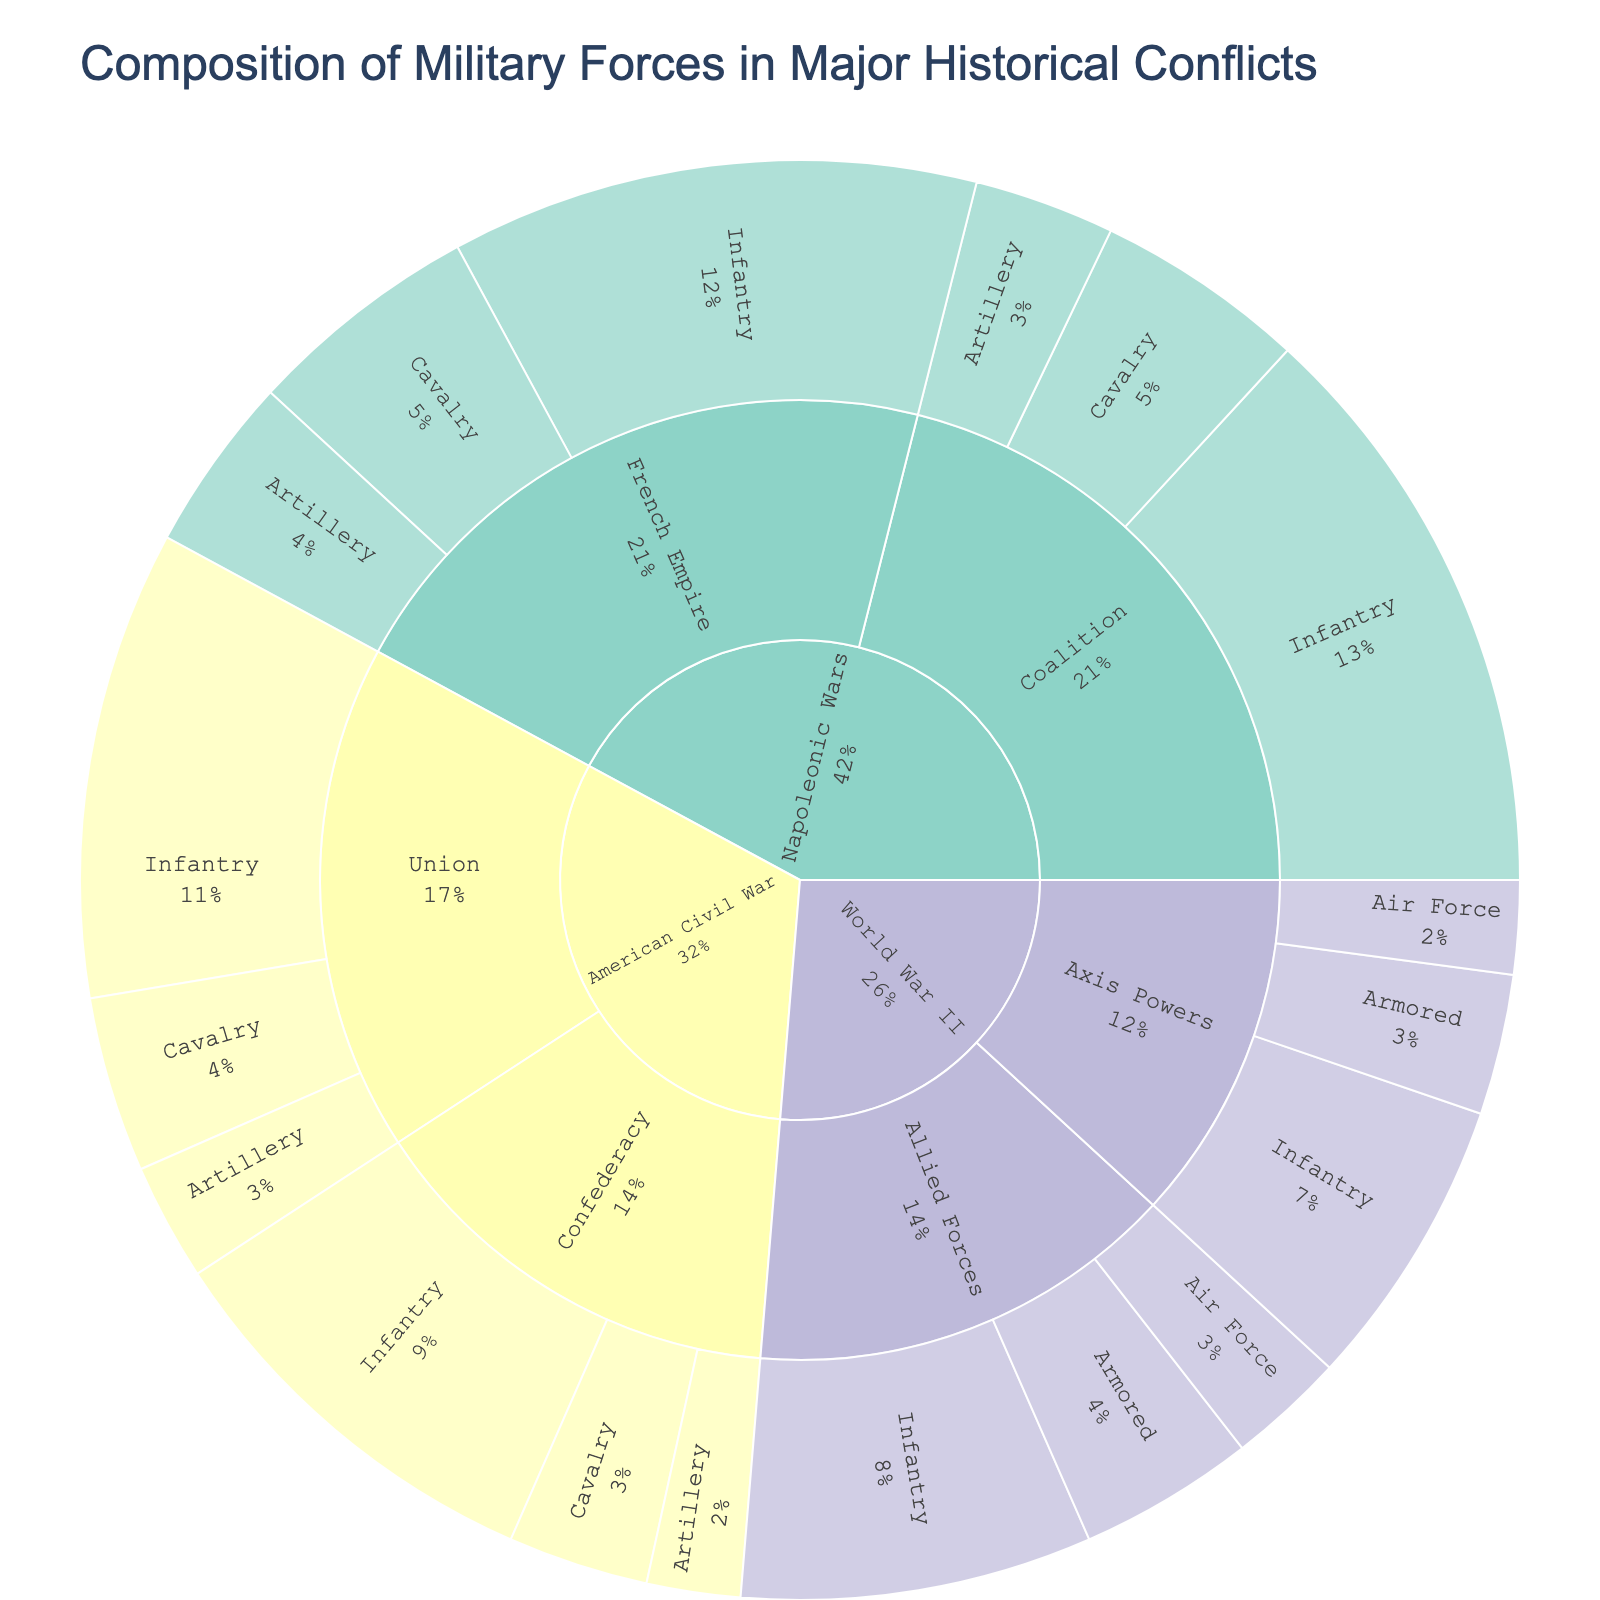What is the total percentage of infantry units in World War II? In the World War II category, the infantry units for Allied Forces and Axis Powers are 30 and 25 respectively. The total infantry value is 55, out of the overall World War II total of 105 (30+15+10 from Allied Forces and 25+12+8 from Axis Powers). So, the percentage is (55/105) * 100
Answer: 52.38% Which conflict has the highest proportion of infantry units? Compare the proportion of infantry units within each major conflict: World War II (55/105 = 52.38%), American Civil War (75/120 = 62.5%), Napoleonic Wars (95/160 = 59.38%). The American Civil War has the highest proportion of infantry units.
Answer: American Civil War How does the proportion of armored units in World War II compare between Allied Forces and Axis Powers? Allied Forces have 15 armored units out of their 55 total, and Axis Powers have 12 armored units out of their 45 total. The proportions are 15/55 = 27.27% for Allied Forces and 12/45 = 26.67% for Axis Powers, showing that the proportions are very close.
Answer: Allied Forces: 27.27%, Axis Powers: 26.67% What percentage of the total military forces in the Napoleonic Wars is made up of cavalry units? In the Napoleonic Wars, there are 20 cavalry units under the French Empire and 18 under the Coalition, totaling 38 out of 160 units (total of 45+20+15 and 50+18+12 under French Empire and Coalition respectively). The percentage is (38/160) * 100
Answer: 23.75% How many total units were involved in the American Civil War? Sum the values of all subcategories under the American Civil War: Union (40+15+10) and Confederacy (35+12+8). The total is 40+15+10+35+12+8
Answer: 120 Which coalition has more artillery units during the Napoleonic Wars, the French Empire or the Coalition? By looking at the artillery values under the Napoleonic Wars category, the French Empire has 15 artillery units, and the Coalition has 12 artillery units.
Answer: French Empire What is the percentage of Union cavalry units relative to all Union units in the American Civil War? The Union has 15 cavalry units out of a total of 65 (40+15+10), making the percentage (15/65) * 100
Answer: 23.08% How does the size of the Air Force in World War II compare between the Allied and Axis Powers? Compare the Air Force units for Allied Forces (10) and Axis Powers (8) under the World War II category. The Allied Forces have 2 more units.
Answer: Allied Forces have 2 more units 